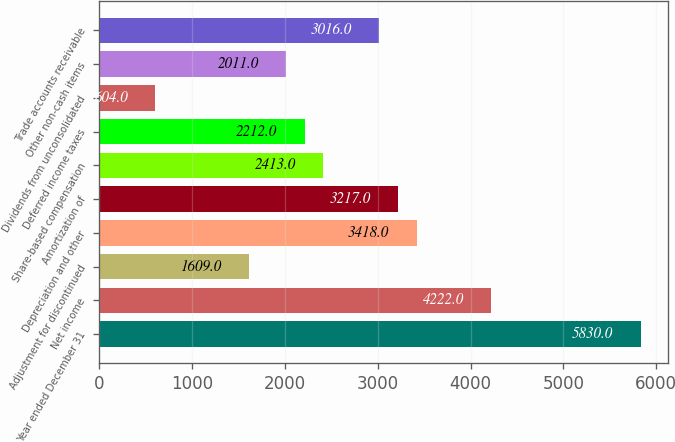Convert chart to OTSL. <chart><loc_0><loc_0><loc_500><loc_500><bar_chart><fcel>Year ended December 31<fcel>Net income<fcel>Adjustment for discontinued<fcel>Depreciation and other<fcel>Amortization of<fcel>Share-based compensation<fcel>Deferred income taxes<fcel>Dividends from unconsolidated<fcel>Other non-cash items<fcel>Trade accounts receivable<nl><fcel>5830<fcel>4222<fcel>1609<fcel>3418<fcel>3217<fcel>2413<fcel>2212<fcel>604<fcel>2011<fcel>3016<nl></chart> 